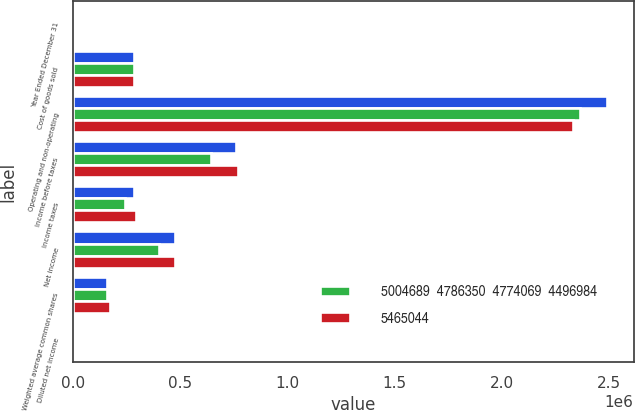Convert chart to OTSL. <chart><loc_0><loc_0><loc_500><loc_500><stacked_bar_chart><ecel><fcel>Year Ended December 31<fcel>Cost of goods sold<fcel>Operating and non-operating<fcel>Income before taxes<fcel>Income taxes<fcel>Net income<fcel>Weighted average common shares<fcel>Diluted net income<nl><fcel>nan<fcel>2010<fcel>286272<fcel>2.49116e+06<fcel>761783<fcel>286272<fcel>475511<fcel>158461<fcel>3<nl><fcel>5004689  4786350  4774069  4496984<fcel>2009<fcel>286272<fcel>2.3656e+06<fcel>644165<fcel>244590<fcel>399575<fcel>159707<fcel>2.5<nl><fcel>5465044<fcel>2006<fcel>286272<fcel>2.33358e+06<fcel>770916<fcel>295511<fcel>475405<fcel>172486<fcel>2.76<nl></chart> 